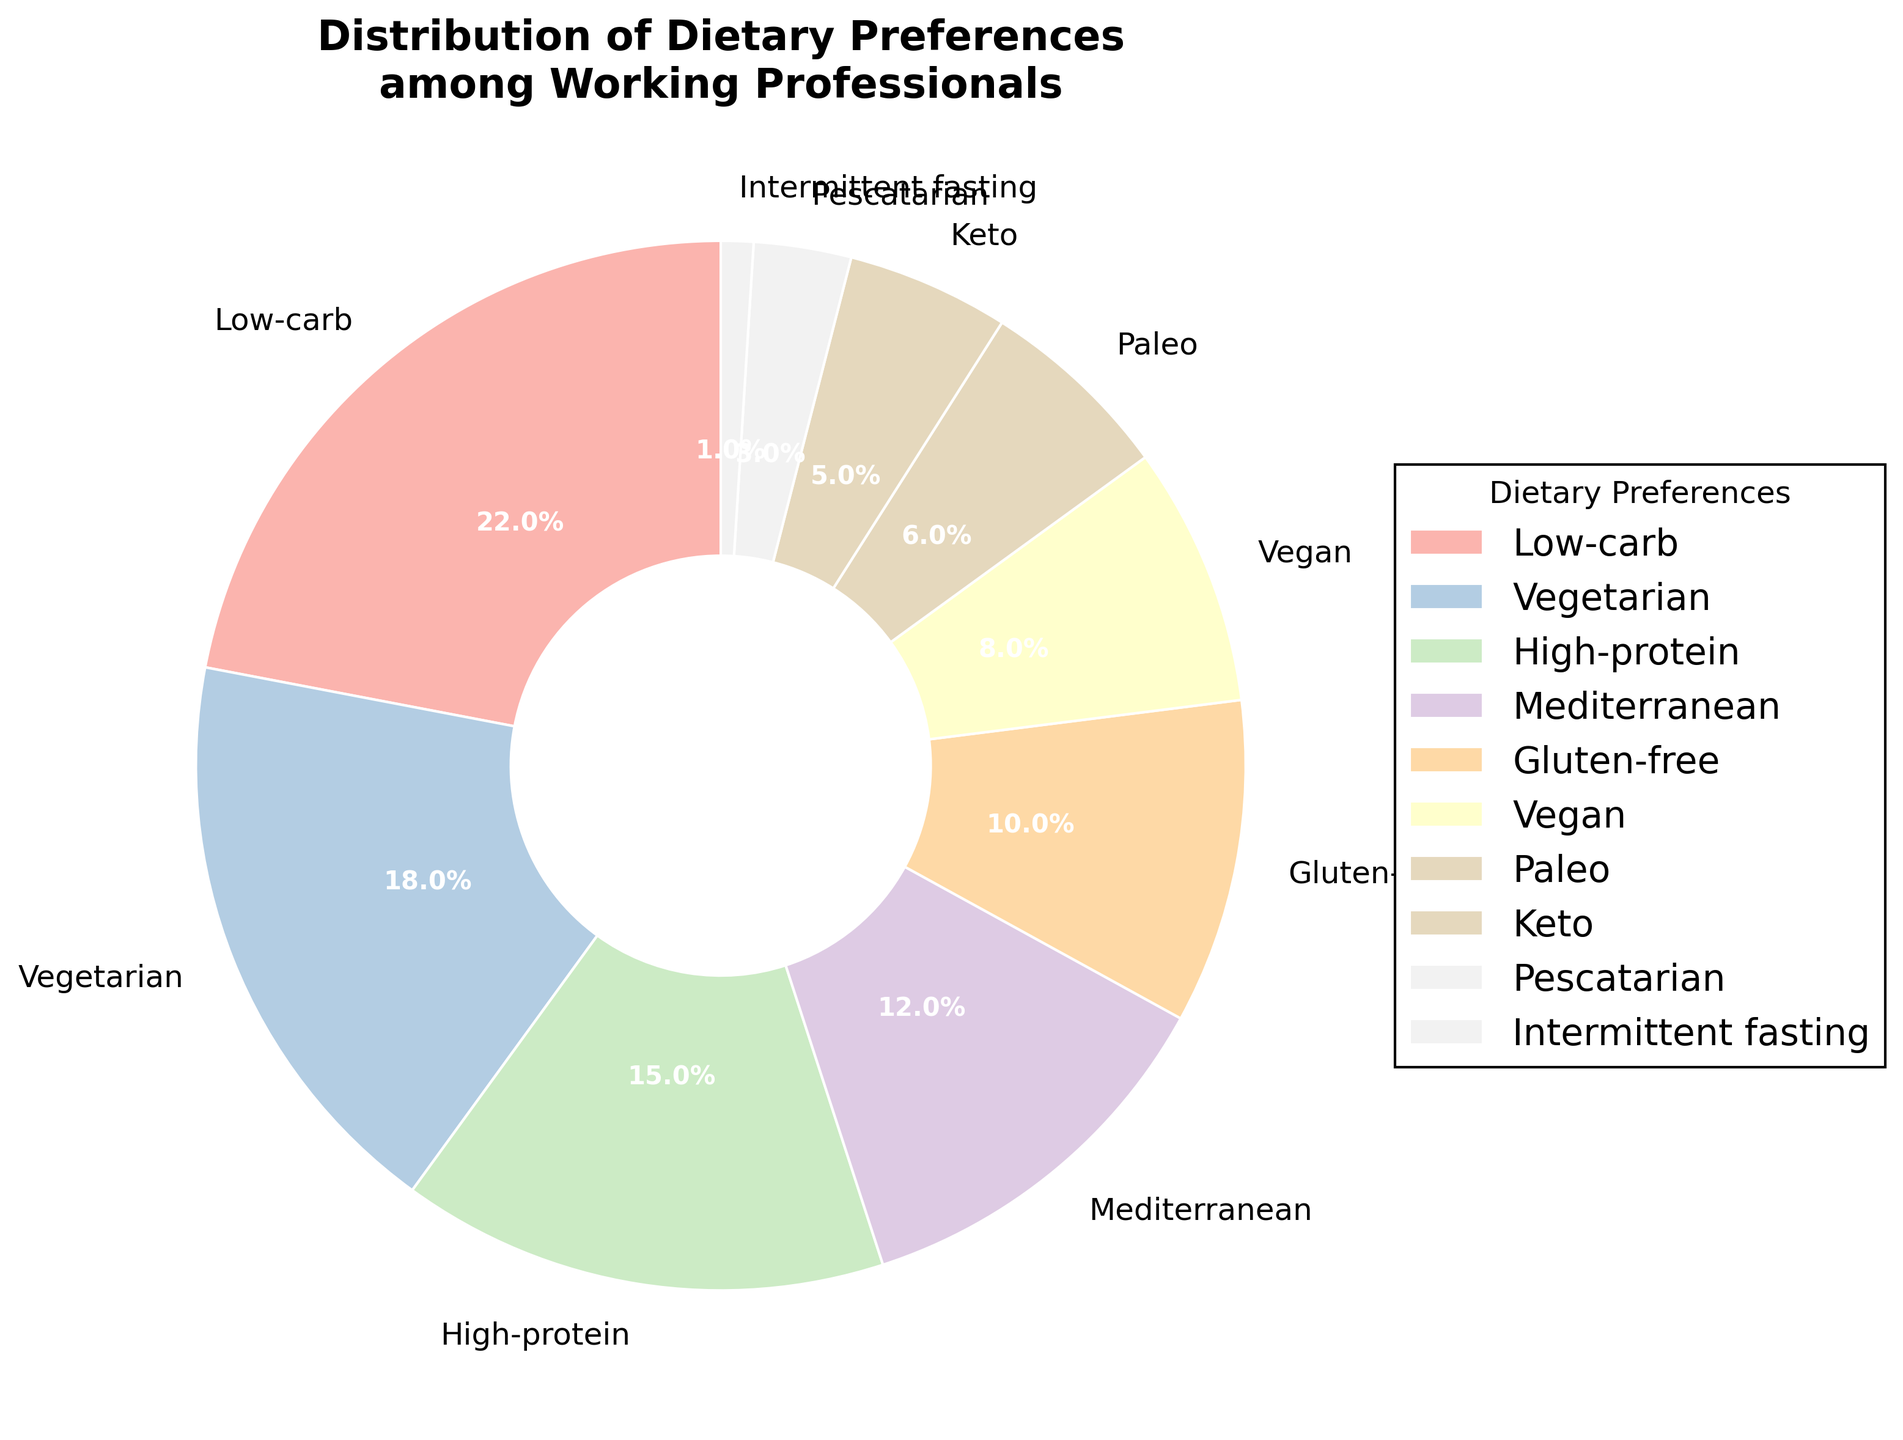What's the most popular dietary preference among working professionals? The largest segment in the pie chart represents the most popular dietary preference. By looking at the sizes of the segments, the "Low-carb" segment appears the largest.
Answer: Low-carb Which dietary preferences have a combined percentage greater than or equal to 30%? To find the combined percentage, we sum up individual percentages. "Low-carb" (22%) + "Vegetarian" (18%) = 40%, which is greater than 30%.
Answer: Low-carb, Vegetarian What's the combined percentage of the least popular dietary preferences, and which ones are they? The least popular dietary preferences are "Pescatarian" (3%) and "Intermittent fasting" (1%). Summing their percentages, we get 3% + 1% = 4%.
Answer: 4%, Pescatarian and Intermittent fasting Which dietary preference segments are more popular than Gluten-free? "Gluten-free" has 10%. Any segment with a percentage greater than 10% is considered. These are "Low-carb" (22%), "Vegetarian" (18%), and "High-protein" (15%).
Answer: Low-carb, Vegetarian, High-protein How does the popularity of the Mediterranean diet compare with the Vegan diet? The "Mediterranean" diet has 12%, while the "Vegan" diet has 8%. So, the Mediterranean diet is more popular.
Answer: Mediterranean is more popular Calculate the combined percentage of Mediterranean and Keto diets. Is it greater than or equal to the percentage of the Low-carb diet? The "Mediterranean" has 12% and "Keto" has 5%. The combined percentage is 12% + 5% = 17%. The "Low-carb" diet is 22%, so 17% is less than 22%.
Answer: No, it's less What is the total percentage of working professionals who prefer either a High-protein or a Vegan diet? "High-protein" has 15% and "Vegan" has 8%. The total percentage is 15% + 8% = 23%.
Answer: 23% If you sum up the percentages of the Vegan and Gluten-free dietary preferences, do they total more or less than the percentage of the Paleo dietary preference? "Vegan" has 8%, "Gluten-free" has 10%, and "Paleo" has 6%. Summing Vegan and Gluten-free gives 8% + 10% = 18%, which is more than 6%.
Answer: More 